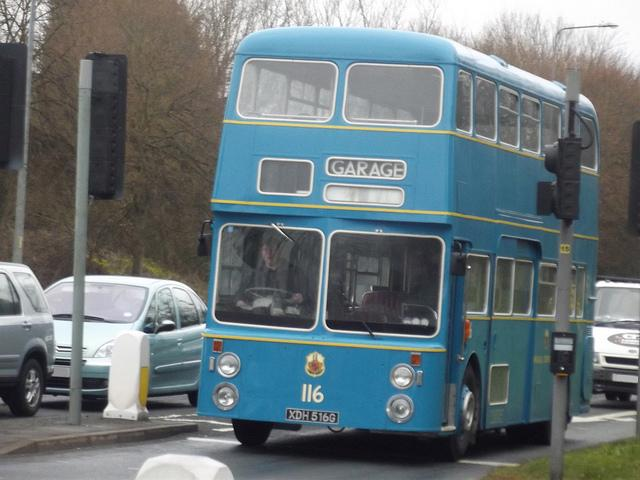Why is the bus without passengers? broken 